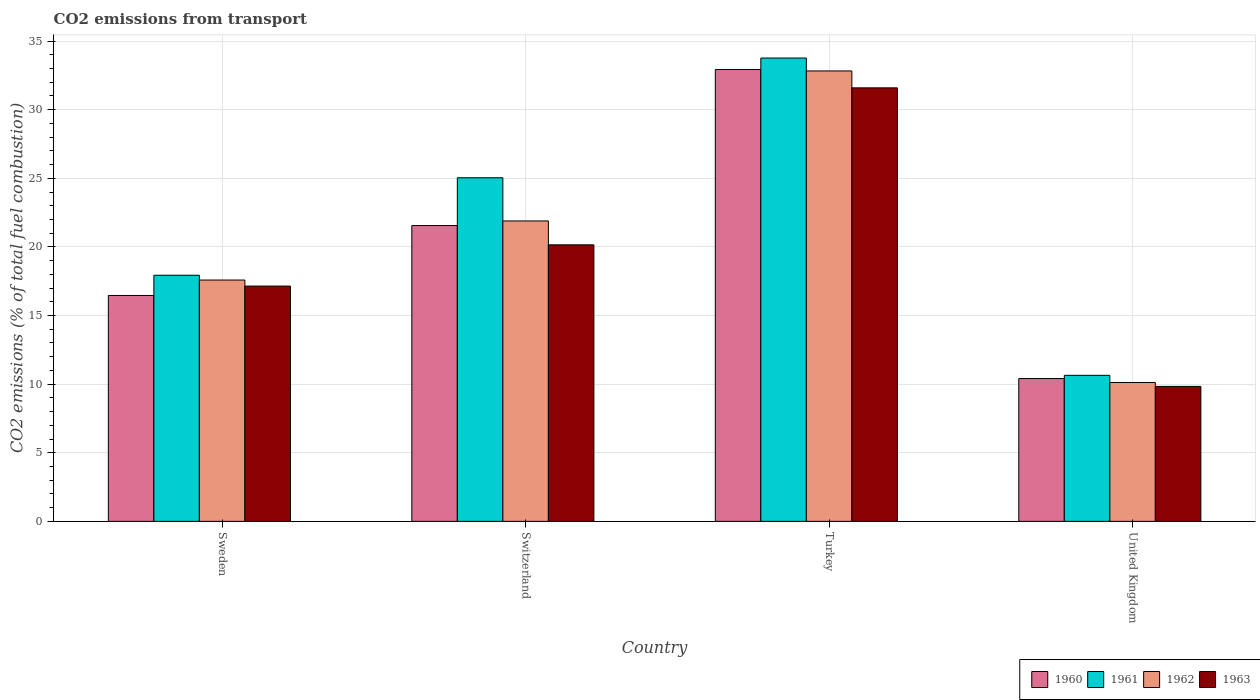How many different coloured bars are there?
Your response must be concise. 4. How many bars are there on the 4th tick from the left?
Offer a very short reply. 4. How many bars are there on the 2nd tick from the right?
Your response must be concise. 4. What is the label of the 2nd group of bars from the left?
Give a very brief answer. Switzerland. In how many cases, is the number of bars for a given country not equal to the number of legend labels?
Your response must be concise. 0. What is the total CO2 emitted in 1961 in Sweden?
Offer a terse response. 17.94. Across all countries, what is the maximum total CO2 emitted in 1963?
Give a very brief answer. 31.59. Across all countries, what is the minimum total CO2 emitted in 1962?
Make the answer very short. 10.12. In which country was the total CO2 emitted in 1962 maximum?
Provide a short and direct response. Turkey. What is the total total CO2 emitted in 1963 in the graph?
Offer a terse response. 78.72. What is the difference between the total CO2 emitted in 1961 in Switzerland and that in Turkey?
Make the answer very short. -8.72. What is the difference between the total CO2 emitted in 1961 in United Kingdom and the total CO2 emitted in 1960 in Switzerland?
Offer a very short reply. -10.91. What is the average total CO2 emitted in 1962 per country?
Make the answer very short. 20.61. What is the difference between the total CO2 emitted of/in 1961 and total CO2 emitted of/in 1962 in Turkey?
Your answer should be compact. 0.94. What is the ratio of the total CO2 emitted in 1963 in Switzerland to that in Turkey?
Make the answer very short. 0.64. What is the difference between the highest and the second highest total CO2 emitted in 1961?
Provide a succinct answer. 8.72. What is the difference between the highest and the lowest total CO2 emitted in 1962?
Ensure brevity in your answer.  22.7. In how many countries, is the total CO2 emitted in 1961 greater than the average total CO2 emitted in 1961 taken over all countries?
Ensure brevity in your answer.  2. Is it the case that in every country, the sum of the total CO2 emitted in 1960 and total CO2 emitted in 1961 is greater than the sum of total CO2 emitted in 1963 and total CO2 emitted in 1962?
Provide a short and direct response. No. What does the 1st bar from the right in United Kingdom represents?
Provide a short and direct response. 1963. Is it the case that in every country, the sum of the total CO2 emitted in 1962 and total CO2 emitted in 1961 is greater than the total CO2 emitted in 1960?
Give a very brief answer. Yes. Does the graph contain any zero values?
Make the answer very short. No. Where does the legend appear in the graph?
Keep it short and to the point. Bottom right. How many legend labels are there?
Offer a very short reply. 4. How are the legend labels stacked?
Your answer should be very brief. Horizontal. What is the title of the graph?
Your answer should be compact. CO2 emissions from transport. Does "1980" appear as one of the legend labels in the graph?
Make the answer very short. No. What is the label or title of the Y-axis?
Your response must be concise. CO2 emissions (% of total fuel combustion). What is the CO2 emissions (% of total fuel combustion) in 1960 in Sweden?
Make the answer very short. 16.46. What is the CO2 emissions (% of total fuel combustion) of 1961 in Sweden?
Ensure brevity in your answer.  17.94. What is the CO2 emissions (% of total fuel combustion) in 1962 in Sweden?
Provide a short and direct response. 17.59. What is the CO2 emissions (% of total fuel combustion) of 1963 in Sweden?
Provide a short and direct response. 17.15. What is the CO2 emissions (% of total fuel combustion) in 1960 in Switzerland?
Your response must be concise. 21.56. What is the CO2 emissions (% of total fuel combustion) of 1961 in Switzerland?
Offer a terse response. 25.04. What is the CO2 emissions (% of total fuel combustion) in 1962 in Switzerland?
Provide a succinct answer. 21.89. What is the CO2 emissions (% of total fuel combustion) of 1963 in Switzerland?
Your answer should be very brief. 20.15. What is the CO2 emissions (% of total fuel combustion) in 1960 in Turkey?
Ensure brevity in your answer.  32.93. What is the CO2 emissions (% of total fuel combustion) of 1961 in Turkey?
Offer a very short reply. 33.76. What is the CO2 emissions (% of total fuel combustion) in 1962 in Turkey?
Ensure brevity in your answer.  32.82. What is the CO2 emissions (% of total fuel combustion) in 1963 in Turkey?
Keep it short and to the point. 31.59. What is the CO2 emissions (% of total fuel combustion) in 1960 in United Kingdom?
Offer a terse response. 10.41. What is the CO2 emissions (% of total fuel combustion) of 1961 in United Kingdom?
Make the answer very short. 10.64. What is the CO2 emissions (% of total fuel combustion) of 1962 in United Kingdom?
Make the answer very short. 10.12. What is the CO2 emissions (% of total fuel combustion) in 1963 in United Kingdom?
Your answer should be very brief. 9.83. Across all countries, what is the maximum CO2 emissions (% of total fuel combustion) of 1960?
Ensure brevity in your answer.  32.93. Across all countries, what is the maximum CO2 emissions (% of total fuel combustion) of 1961?
Your answer should be compact. 33.76. Across all countries, what is the maximum CO2 emissions (% of total fuel combustion) in 1962?
Provide a short and direct response. 32.82. Across all countries, what is the maximum CO2 emissions (% of total fuel combustion) in 1963?
Provide a short and direct response. 31.59. Across all countries, what is the minimum CO2 emissions (% of total fuel combustion) of 1960?
Your answer should be very brief. 10.41. Across all countries, what is the minimum CO2 emissions (% of total fuel combustion) of 1961?
Your answer should be compact. 10.64. Across all countries, what is the minimum CO2 emissions (% of total fuel combustion) of 1962?
Your answer should be compact. 10.12. Across all countries, what is the minimum CO2 emissions (% of total fuel combustion) of 1963?
Keep it short and to the point. 9.83. What is the total CO2 emissions (% of total fuel combustion) in 1960 in the graph?
Give a very brief answer. 81.36. What is the total CO2 emissions (% of total fuel combustion) of 1961 in the graph?
Give a very brief answer. 87.38. What is the total CO2 emissions (% of total fuel combustion) in 1962 in the graph?
Your response must be concise. 82.42. What is the total CO2 emissions (% of total fuel combustion) in 1963 in the graph?
Give a very brief answer. 78.72. What is the difference between the CO2 emissions (% of total fuel combustion) in 1960 in Sweden and that in Switzerland?
Give a very brief answer. -5.09. What is the difference between the CO2 emissions (% of total fuel combustion) in 1961 in Sweden and that in Switzerland?
Your response must be concise. -7.1. What is the difference between the CO2 emissions (% of total fuel combustion) in 1962 in Sweden and that in Switzerland?
Your answer should be compact. -4.31. What is the difference between the CO2 emissions (% of total fuel combustion) of 1963 in Sweden and that in Switzerland?
Provide a succinct answer. -3.01. What is the difference between the CO2 emissions (% of total fuel combustion) in 1960 in Sweden and that in Turkey?
Your response must be concise. -16.47. What is the difference between the CO2 emissions (% of total fuel combustion) in 1961 in Sweden and that in Turkey?
Ensure brevity in your answer.  -15.83. What is the difference between the CO2 emissions (% of total fuel combustion) in 1962 in Sweden and that in Turkey?
Your answer should be very brief. -15.24. What is the difference between the CO2 emissions (% of total fuel combustion) in 1963 in Sweden and that in Turkey?
Give a very brief answer. -14.44. What is the difference between the CO2 emissions (% of total fuel combustion) in 1960 in Sweden and that in United Kingdom?
Make the answer very short. 6.05. What is the difference between the CO2 emissions (% of total fuel combustion) of 1961 in Sweden and that in United Kingdom?
Offer a terse response. 7.29. What is the difference between the CO2 emissions (% of total fuel combustion) of 1962 in Sweden and that in United Kingdom?
Your response must be concise. 7.47. What is the difference between the CO2 emissions (% of total fuel combustion) of 1963 in Sweden and that in United Kingdom?
Provide a succinct answer. 7.31. What is the difference between the CO2 emissions (% of total fuel combustion) of 1960 in Switzerland and that in Turkey?
Offer a terse response. -11.37. What is the difference between the CO2 emissions (% of total fuel combustion) in 1961 in Switzerland and that in Turkey?
Make the answer very short. -8.72. What is the difference between the CO2 emissions (% of total fuel combustion) of 1962 in Switzerland and that in Turkey?
Give a very brief answer. -10.93. What is the difference between the CO2 emissions (% of total fuel combustion) in 1963 in Switzerland and that in Turkey?
Your answer should be compact. -11.44. What is the difference between the CO2 emissions (% of total fuel combustion) in 1960 in Switzerland and that in United Kingdom?
Ensure brevity in your answer.  11.15. What is the difference between the CO2 emissions (% of total fuel combustion) of 1961 in Switzerland and that in United Kingdom?
Offer a terse response. 14.4. What is the difference between the CO2 emissions (% of total fuel combustion) in 1962 in Switzerland and that in United Kingdom?
Your answer should be very brief. 11.77. What is the difference between the CO2 emissions (% of total fuel combustion) in 1963 in Switzerland and that in United Kingdom?
Keep it short and to the point. 10.32. What is the difference between the CO2 emissions (% of total fuel combustion) of 1960 in Turkey and that in United Kingdom?
Provide a short and direct response. 22.52. What is the difference between the CO2 emissions (% of total fuel combustion) in 1961 in Turkey and that in United Kingdom?
Ensure brevity in your answer.  23.12. What is the difference between the CO2 emissions (% of total fuel combustion) of 1962 in Turkey and that in United Kingdom?
Your answer should be very brief. 22.7. What is the difference between the CO2 emissions (% of total fuel combustion) of 1963 in Turkey and that in United Kingdom?
Your answer should be very brief. 21.76. What is the difference between the CO2 emissions (% of total fuel combustion) in 1960 in Sweden and the CO2 emissions (% of total fuel combustion) in 1961 in Switzerland?
Offer a terse response. -8.58. What is the difference between the CO2 emissions (% of total fuel combustion) in 1960 in Sweden and the CO2 emissions (% of total fuel combustion) in 1962 in Switzerland?
Provide a succinct answer. -5.43. What is the difference between the CO2 emissions (% of total fuel combustion) in 1960 in Sweden and the CO2 emissions (% of total fuel combustion) in 1963 in Switzerland?
Keep it short and to the point. -3.69. What is the difference between the CO2 emissions (% of total fuel combustion) of 1961 in Sweden and the CO2 emissions (% of total fuel combustion) of 1962 in Switzerland?
Offer a terse response. -3.96. What is the difference between the CO2 emissions (% of total fuel combustion) of 1961 in Sweden and the CO2 emissions (% of total fuel combustion) of 1963 in Switzerland?
Your answer should be compact. -2.22. What is the difference between the CO2 emissions (% of total fuel combustion) of 1962 in Sweden and the CO2 emissions (% of total fuel combustion) of 1963 in Switzerland?
Keep it short and to the point. -2.57. What is the difference between the CO2 emissions (% of total fuel combustion) in 1960 in Sweden and the CO2 emissions (% of total fuel combustion) in 1961 in Turkey?
Keep it short and to the point. -17.3. What is the difference between the CO2 emissions (% of total fuel combustion) of 1960 in Sweden and the CO2 emissions (% of total fuel combustion) of 1962 in Turkey?
Offer a very short reply. -16.36. What is the difference between the CO2 emissions (% of total fuel combustion) of 1960 in Sweden and the CO2 emissions (% of total fuel combustion) of 1963 in Turkey?
Offer a terse response. -15.13. What is the difference between the CO2 emissions (% of total fuel combustion) in 1961 in Sweden and the CO2 emissions (% of total fuel combustion) in 1962 in Turkey?
Provide a short and direct response. -14.89. What is the difference between the CO2 emissions (% of total fuel combustion) of 1961 in Sweden and the CO2 emissions (% of total fuel combustion) of 1963 in Turkey?
Provide a succinct answer. -13.66. What is the difference between the CO2 emissions (% of total fuel combustion) in 1962 in Sweden and the CO2 emissions (% of total fuel combustion) in 1963 in Turkey?
Offer a very short reply. -14.01. What is the difference between the CO2 emissions (% of total fuel combustion) of 1960 in Sweden and the CO2 emissions (% of total fuel combustion) of 1961 in United Kingdom?
Ensure brevity in your answer.  5.82. What is the difference between the CO2 emissions (% of total fuel combustion) in 1960 in Sweden and the CO2 emissions (% of total fuel combustion) in 1962 in United Kingdom?
Offer a very short reply. 6.34. What is the difference between the CO2 emissions (% of total fuel combustion) in 1960 in Sweden and the CO2 emissions (% of total fuel combustion) in 1963 in United Kingdom?
Your answer should be very brief. 6.63. What is the difference between the CO2 emissions (% of total fuel combustion) in 1961 in Sweden and the CO2 emissions (% of total fuel combustion) in 1962 in United Kingdom?
Keep it short and to the point. 7.82. What is the difference between the CO2 emissions (% of total fuel combustion) of 1961 in Sweden and the CO2 emissions (% of total fuel combustion) of 1963 in United Kingdom?
Give a very brief answer. 8.1. What is the difference between the CO2 emissions (% of total fuel combustion) of 1962 in Sweden and the CO2 emissions (% of total fuel combustion) of 1963 in United Kingdom?
Offer a very short reply. 7.75. What is the difference between the CO2 emissions (% of total fuel combustion) in 1960 in Switzerland and the CO2 emissions (% of total fuel combustion) in 1961 in Turkey?
Your response must be concise. -12.21. What is the difference between the CO2 emissions (% of total fuel combustion) of 1960 in Switzerland and the CO2 emissions (% of total fuel combustion) of 1962 in Turkey?
Provide a short and direct response. -11.27. What is the difference between the CO2 emissions (% of total fuel combustion) in 1960 in Switzerland and the CO2 emissions (% of total fuel combustion) in 1963 in Turkey?
Ensure brevity in your answer.  -10.04. What is the difference between the CO2 emissions (% of total fuel combustion) of 1961 in Switzerland and the CO2 emissions (% of total fuel combustion) of 1962 in Turkey?
Give a very brief answer. -7.78. What is the difference between the CO2 emissions (% of total fuel combustion) of 1961 in Switzerland and the CO2 emissions (% of total fuel combustion) of 1963 in Turkey?
Give a very brief answer. -6.55. What is the difference between the CO2 emissions (% of total fuel combustion) of 1962 in Switzerland and the CO2 emissions (% of total fuel combustion) of 1963 in Turkey?
Make the answer very short. -9.7. What is the difference between the CO2 emissions (% of total fuel combustion) in 1960 in Switzerland and the CO2 emissions (% of total fuel combustion) in 1961 in United Kingdom?
Provide a succinct answer. 10.91. What is the difference between the CO2 emissions (% of total fuel combustion) of 1960 in Switzerland and the CO2 emissions (% of total fuel combustion) of 1962 in United Kingdom?
Give a very brief answer. 11.44. What is the difference between the CO2 emissions (% of total fuel combustion) in 1960 in Switzerland and the CO2 emissions (% of total fuel combustion) in 1963 in United Kingdom?
Make the answer very short. 11.72. What is the difference between the CO2 emissions (% of total fuel combustion) in 1961 in Switzerland and the CO2 emissions (% of total fuel combustion) in 1962 in United Kingdom?
Keep it short and to the point. 14.92. What is the difference between the CO2 emissions (% of total fuel combustion) in 1961 in Switzerland and the CO2 emissions (% of total fuel combustion) in 1963 in United Kingdom?
Your answer should be very brief. 15.21. What is the difference between the CO2 emissions (% of total fuel combustion) in 1962 in Switzerland and the CO2 emissions (% of total fuel combustion) in 1963 in United Kingdom?
Provide a short and direct response. 12.06. What is the difference between the CO2 emissions (% of total fuel combustion) in 1960 in Turkey and the CO2 emissions (% of total fuel combustion) in 1961 in United Kingdom?
Provide a short and direct response. 22.29. What is the difference between the CO2 emissions (% of total fuel combustion) of 1960 in Turkey and the CO2 emissions (% of total fuel combustion) of 1962 in United Kingdom?
Your answer should be compact. 22.81. What is the difference between the CO2 emissions (% of total fuel combustion) of 1960 in Turkey and the CO2 emissions (% of total fuel combustion) of 1963 in United Kingdom?
Give a very brief answer. 23.1. What is the difference between the CO2 emissions (% of total fuel combustion) in 1961 in Turkey and the CO2 emissions (% of total fuel combustion) in 1962 in United Kingdom?
Your answer should be compact. 23.64. What is the difference between the CO2 emissions (% of total fuel combustion) of 1961 in Turkey and the CO2 emissions (% of total fuel combustion) of 1963 in United Kingdom?
Provide a succinct answer. 23.93. What is the difference between the CO2 emissions (% of total fuel combustion) of 1962 in Turkey and the CO2 emissions (% of total fuel combustion) of 1963 in United Kingdom?
Provide a short and direct response. 22.99. What is the average CO2 emissions (% of total fuel combustion) in 1960 per country?
Offer a terse response. 20.34. What is the average CO2 emissions (% of total fuel combustion) in 1961 per country?
Ensure brevity in your answer.  21.85. What is the average CO2 emissions (% of total fuel combustion) in 1962 per country?
Your answer should be compact. 20.61. What is the average CO2 emissions (% of total fuel combustion) of 1963 per country?
Offer a terse response. 19.68. What is the difference between the CO2 emissions (% of total fuel combustion) of 1960 and CO2 emissions (% of total fuel combustion) of 1961 in Sweden?
Your answer should be compact. -1.47. What is the difference between the CO2 emissions (% of total fuel combustion) of 1960 and CO2 emissions (% of total fuel combustion) of 1962 in Sweden?
Your answer should be compact. -1.12. What is the difference between the CO2 emissions (% of total fuel combustion) of 1960 and CO2 emissions (% of total fuel combustion) of 1963 in Sweden?
Provide a succinct answer. -0.69. What is the difference between the CO2 emissions (% of total fuel combustion) in 1961 and CO2 emissions (% of total fuel combustion) in 1962 in Sweden?
Keep it short and to the point. 0.35. What is the difference between the CO2 emissions (% of total fuel combustion) in 1961 and CO2 emissions (% of total fuel combustion) in 1963 in Sweden?
Ensure brevity in your answer.  0.79. What is the difference between the CO2 emissions (% of total fuel combustion) in 1962 and CO2 emissions (% of total fuel combustion) in 1963 in Sweden?
Give a very brief answer. 0.44. What is the difference between the CO2 emissions (% of total fuel combustion) in 1960 and CO2 emissions (% of total fuel combustion) in 1961 in Switzerland?
Your response must be concise. -3.48. What is the difference between the CO2 emissions (% of total fuel combustion) in 1960 and CO2 emissions (% of total fuel combustion) in 1962 in Switzerland?
Your answer should be compact. -0.34. What is the difference between the CO2 emissions (% of total fuel combustion) of 1960 and CO2 emissions (% of total fuel combustion) of 1963 in Switzerland?
Offer a terse response. 1.4. What is the difference between the CO2 emissions (% of total fuel combustion) of 1961 and CO2 emissions (% of total fuel combustion) of 1962 in Switzerland?
Provide a succinct answer. 3.15. What is the difference between the CO2 emissions (% of total fuel combustion) of 1961 and CO2 emissions (% of total fuel combustion) of 1963 in Switzerland?
Your answer should be very brief. 4.89. What is the difference between the CO2 emissions (% of total fuel combustion) in 1962 and CO2 emissions (% of total fuel combustion) in 1963 in Switzerland?
Your answer should be compact. 1.74. What is the difference between the CO2 emissions (% of total fuel combustion) of 1960 and CO2 emissions (% of total fuel combustion) of 1961 in Turkey?
Provide a short and direct response. -0.84. What is the difference between the CO2 emissions (% of total fuel combustion) of 1960 and CO2 emissions (% of total fuel combustion) of 1962 in Turkey?
Keep it short and to the point. 0.1. What is the difference between the CO2 emissions (% of total fuel combustion) in 1960 and CO2 emissions (% of total fuel combustion) in 1963 in Turkey?
Provide a succinct answer. 1.34. What is the difference between the CO2 emissions (% of total fuel combustion) in 1961 and CO2 emissions (% of total fuel combustion) in 1962 in Turkey?
Provide a short and direct response. 0.94. What is the difference between the CO2 emissions (% of total fuel combustion) in 1961 and CO2 emissions (% of total fuel combustion) in 1963 in Turkey?
Ensure brevity in your answer.  2.17. What is the difference between the CO2 emissions (% of total fuel combustion) of 1962 and CO2 emissions (% of total fuel combustion) of 1963 in Turkey?
Keep it short and to the point. 1.23. What is the difference between the CO2 emissions (% of total fuel combustion) in 1960 and CO2 emissions (% of total fuel combustion) in 1961 in United Kingdom?
Keep it short and to the point. -0.23. What is the difference between the CO2 emissions (% of total fuel combustion) in 1960 and CO2 emissions (% of total fuel combustion) in 1962 in United Kingdom?
Provide a short and direct response. 0.29. What is the difference between the CO2 emissions (% of total fuel combustion) of 1960 and CO2 emissions (% of total fuel combustion) of 1963 in United Kingdom?
Offer a very short reply. 0.58. What is the difference between the CO2 emissions (% of total fuel combustion) of 1961 and CO2 emissions (% of total fuel combustion) of 1962 in United Kingdom?
Your response must be concise. 0.52. What is the difference between the CO2 emissions (% of total fuel combustion) of 1961 and CO2 emissions (% of total fuel combustion) of 1963 in United Kingdom?
Provide a short and direct response. 0.81. What is the difference between the CO2 emissions (% of total fuel combustion) in 1962 and CO2 emissions (% of total fuel combustion) in 1963 in United Kingdom?
Provide a succinct answer. 0.29. What is the ratio of the CO2 emissions (% of total fuel combustion) of 1960 in Sweden to that in Switzerland?
Your answer should be compact. 0.76. What is the ratio of the CO2 emissions (% of total fuel combustion) of 1961 in Sweden to that in Switzerland?
Ensure brevity in your answer.  0.72. What is the ratio of the CO2 emissions (% of total fuel combustion) of 1962 in Sweden to that in Switzerland?
Offer a very short reply. 0.8. What is the ratio of the CO2 emissions (% of total fuel combustion) in 1963 in Sweden to that in Switzerland?
Make the answer very short. 0.85. What is the ratio of the CO2 emissions (% of total fuel combustion) of 1960 in Sweden to that in Turkey?
Your response must be concise. 0.5. What is the ratio of the CO2 emissions (% of total fuel combustion) of 1961 in Sweden to that in Turkey?
Provide a short and direct response. 0.53. What is the ratio of the CO2 emissions (% of total fuel combustion) in 1962 in Sweden to that in Turkey?
Provide a short and direct response. 0.54. What is the ratio of the CO2 emissions (% of total fuel combustion) in 1963 in Sweden to that in Turkey?
Offer a very short reply. 0.54. What is the ratio of the CO2 emissions (% of total fuel combustion) of 1960 in Sweden to that in United Kingdom?
Offer a terse response. 1.58. What is the ratio of the CO2 emissions (% of total fuel combustion) in 1961 in Sweden to that in United Kingdom?
Provide a short and direct response. 1.69. What is the ratio of the CO2 emissions (% of total fuel combustion) of 1962 in Sweden to that in United Kingdom?
Your answer should be very brief. 1.74. What is the ratio of the CO2 emissions (% of total fuel combustion) in 1963 in Sweden to that in United Kingdom?
Your response must be concise. 1.74. What is the ratio of the CO2 emissions (% of total fuel combustion) of 1960 in Switzerland to that in Turkey?
Offer a terse response. 0.65. What is the ratio of the CO2 emissions (% of total fuel combustion) in 1961 in Switzerland to that in Turkey?
Provide a short and direct response. 0.74. What is the ratio of the CO2 emissions (% of total fuel combustion) of 1962 in Switzerland to that in Turkey?
Offer a very short reply. 0.67. What is the ratio of the CO2 emissions (% of total fuel combustion) of 1963 in Switzerland to that in Turkey?
Keep it short and to the point. 0.64. What is the ratio of the CO2 emissions (% of total fuel combustion) in 1960 in Switzerland to that in United Kingdom?
Provide a short and direct response. 2.07. What is the ratio of the CO2 emissions (% of total fuel combustion) of 1961 in Switzerland to that in United Kingdom?
Your answer should be compact. 2.35. What is the ratio of the CO2 emissions (% of total fuel combustion) of 1962 in Switzerland to that in United Kingdom?
Provide a short and direct response. 2.16. What is the ratio of the CO2 emissions (% of total fuel combustion) in 1963 in Switzerland to that in United Kingdom?
Give a very brief answer. 2.05. What is the ratio of the CO2 emissions (% of total fuel combustion) of 1960 in Turkey to that in United Kingdom?
Ensure brevity in your answer.  3.16. What is the ratio of the CO2 emissions (% of total fuel combustion) in 1961 in Turkey to that in United Kingdom?
Your response must be concise. 3.17. What is the ratio of the CO2 emissions (% of total fuel combustion) of 1962 in Turkey to that in United Kingdom?
Make the answer very short. 3.24. What is the ratio of the CO2 emissions (% of total fuel combustion) of 1963 in Turkey to that in United Kingdom?
Offer a very short reply. 3.21. What is the difference between the highest and the second highest CO2 emissions (% of total fuel combustion) in 1960?
Provide a short and direct response. 11.37. What is the difference between the highest and the second highest CO2 emissions (% of total fuel combustion) of 1961?
Make the answer very short. 8.72. What is the difference between the highest and the second highest CO2 emissions (% of total fuel combustion) of 1962?
Offer a very short reply. 10.93. What is the difference between the highest and the second highest CO2 emissions (% of total fuel combustion) in 1963?
Offer a terse response. 11.44. What is the difference between the highest and the lowest CO2 emissions (% of total fuel combustion) of 1960?
Give a very brief answer. 22.52. What is the difference between the highest and the lowest CO2 emissions (% of total fuel combustion) in 1961?
Give a very brief answer. 23.12. What is the difference between the highest and the lowest CO2 emissions (% of total fuel combustion) of 1962?
Provide a short and direct response. 22.7. What is the difference between the highest and the lowest CO2 emissions (% of total fuel combustion) in 1963?
Provide a short and direct response. 21.76. 